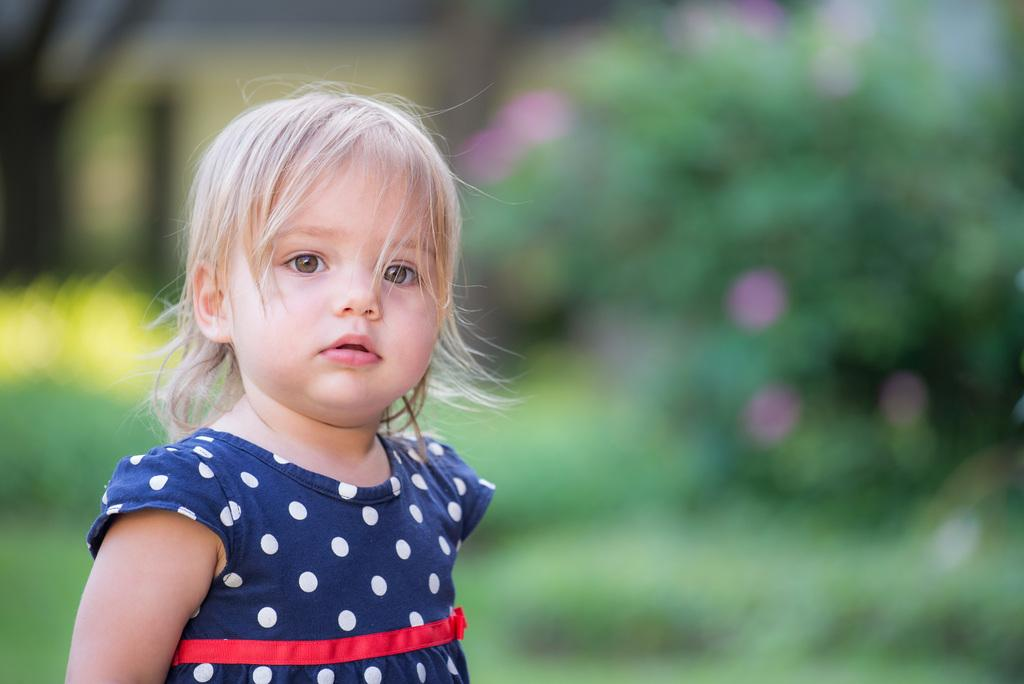What is the main subject of the image? There is a little cute girl in the image. Where is the girl located in the image? The girl is on the left side of the image. What is the girl wearing? The girl is wearing a dress. What type of trains can be seen in the image? There are no trains present in the image; it features a little cute girl wearing a dress. Can you tell me how many robins are visible in the image? There are no robins present in the image. 